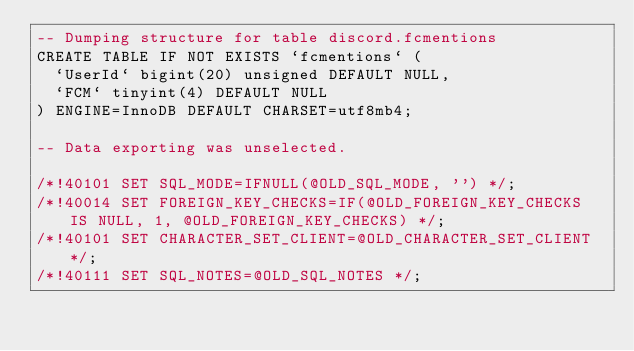Convert code to text. <code><loc_0><loc_0><loc_500><loc_500><_SQL_>-- Dumping structure for table discord.fcmentions
CREATE TABLE IF NOT EXISTS `fcmentions` (
  `UserId` bigint(20) unsigned DEFAULT NULL,
  `FCM` tinyint(4) DEFAULT NULL
) ENGINE=InnoDB DEFAULT CHARSET=utf8mb4;

-- Data exporting was unselected.

/*!40101 SET SQL_MODE=IFNULL(@OLD_SQL_MODE, '') */;
/*!40014 SET FOREIGN_KEY_CHECKS=IF(@OLD_FOREIGN_KEY_CHECKS IS NULL, 1, @OLD_FOREIGN_KEY_CHECKS) */;
/*!40101 SET CHARACTER_SET_CLIENT=@OLD_CHARACTER_SET_CLIENT */;
/*!40111 SET SQL_NOTES=@OLD_SQL_NOTES */;
</code> 